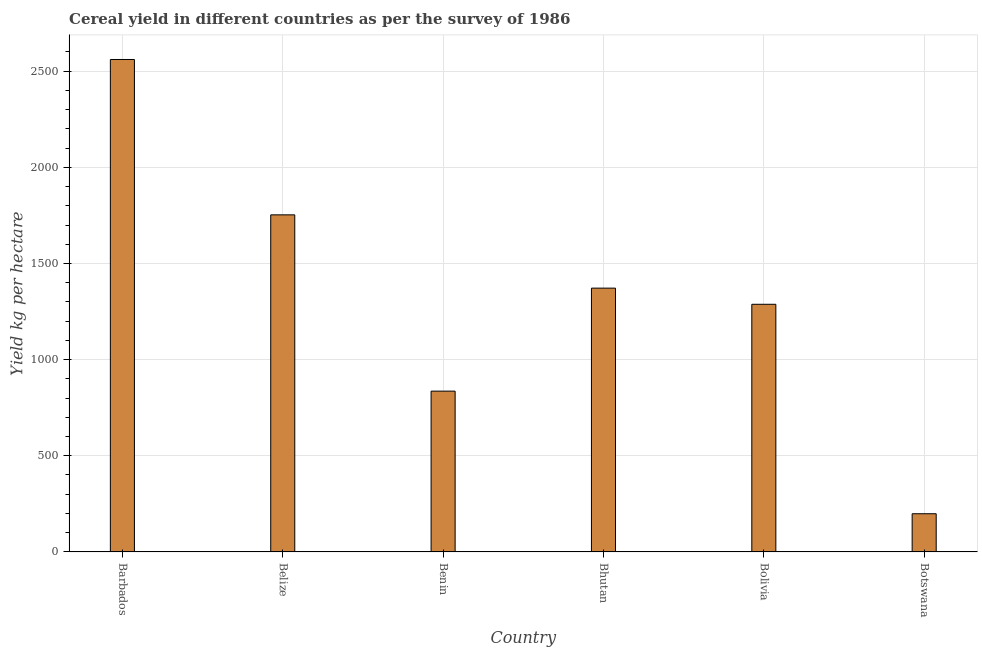Does the graph contain any zero values?
Offer a terse response. No. What is the title of the graph?
Ensure brevity in your answer.  Cereal yield in different countries as per the survey of 1986. What is the label or title of the X-axis?
Make the answer very short. Country. What is the label or title of the Y-axis?
Provide a short and direct response. Yield kg per hectare. What is the cereal yield in Botswana?
Provide a succinct answer. 198.48. Across all countries, what is the maximum cereal yield?
Make the answer very short. 2560.98. Across all countries, what is the minimum cereal yield?
Your response must be concise. 198.48. In which country was the cereal yield maximum?
Offer a very short reply. Barbados. In which country was the cereal yield minimum?
Provide a succinct answer. Botswana. What is the sum of the cereal yield?
Your answer should be compact. 8008.32. What is the difference between the cereal yield in Belize and Bhutan?
Your answer should be very brief. 381.12. What is the average cereal yield per country?
Provide a succinct answer. 1334.72. What is the median cereal yield?
Provide a short and direct response. 1329.86. In how many countries, is the cereal yield greater than 1500 kg per hectare?
Keep it short and to the point. 2. What is the ratio of the cereal yield in Bhutan to that in Bolivia?
Your answer should be very brief. 1.06. Is the cereal yield in Belize less than that in Bolivia?
Your response must be concise. No. Is the difference between the cereal yield in Benin and Bhutan greater than the difference between any two countries?
Your response must be concise. No. What is the difference between the highest and the second highest cereal yield?
Provide a short and direct response. 807.99. Is the sum of the cereal yield in Barbados and Bhutan greater than the maximum cereal yield across all countries?
Your answer should be compact. Yes. What is the difference between the highest and the lowest cereal yield?
Your answer should be very brief. 2362.5. How many bars are there?
Give a very brief answer. 6. What is the Yield kg per hectare of Barbados?
Offer a terse response. 2560.98. What is the Yield kg per hectare of Belize?
Your answer should be very brief. 1752.99. What is the Yield kg per hectare of Benin?
Give a very brief answer. 836.15. What is the Yield kg per hectare of Bhutan?
Offer a very short reply. 1371.87. What is the Yield kg per hectare in Bolivia?
Your answer should be compact. 1287.86. What is the Yield kg per hectare of Botswana?
Offer a very short reply. 198.48. What is the difference between the Yield kg per hectare in Barbados and Belize?
Make the answer very short. 807.99. What is the difference between the Yield kg per hectare in Barbados and Benin?
Provide a succinct answer. 1724.82. What is the difference between the Yield kg per hectare in Barbados and Bhutan?
Your answer should be very brief. 1189.11. What is the difference between the Yield kg per hectare in Barbados and Bolivia?
Your answer should be very brief. 1273.12. What is the difference between the Yield kg per hectare in Barbados and Botswana?
Provide a succinct answer. 2362.5. What is the difference between the Yield kg per hectare in Belize and Benin?
Your response must be concise. 916.83. What is the difference between the Yield kg per hectare in Belize and Bhutan?
Offer a terse response. 381.12. What is the difference between the Yield kg per hectare in Belize and Bolivia?
Your answer should be compact. 465.13. What is the difference between the Yield kg per hectare in Belize and Botswana?
Your answer should be compact. 1554.51. What is the difference between the Yield kg per hectare in Benin and Bhutan?
Give a very brief answer. -535.72. What is the difference between the Yield kg per hectare in Benin and Bolivia?
Offer a very short reply. -451.7. What is the difference between the Yield kg per hectare in Benin and Botswana?
Provide a succinct answer. 637.67. What is the difference between the Yield kg per hectare in Bhutan and Bolivia?
Your response must be concise. 84.01. What is the difference between the Yield kg per hectare in Bhutan and Botswana?
Your answer should be compact. 1173.39. What is the difference between the Yield kg per hectare in Bolivia and Botswana?
Provide a short and direct response. 1089.38. What is the ratio of the Yield kg per hectare in Barbados to that in Belize?
Ensure brevity in your answer.  1.46. What is the ratio of the Yield kg per hectare in Barbados to that in Benin?
Provide a short and direct response. 3.06. What is the ratio of the Yield kg per hectare in Barbados to that in Bhutan?
Keep it short and to the point. 1.87. What is the ratio of the Yield kg per hectare in Barbados to that in Bolivia?
Your response must be concise. 1.99. What is the ratio of the Yield kg per hectare in Barbados to that in Botswana?
Your answer should be compact. 12.9. What is the ratio of the Yield kg per hectare in Belize to that in Benin?
Your response must be concise. 2.1. What is the ratio of the Yield kg per hectare in Belize to that in Bhutan?
Your answer should be compact. 1.28. What is the ratio of the Yield kg per hectare in Belize to that in Bolivia?
Your response must be concise. 1.36. What is the ratio of the Yield kg per hectare in Belize to that in Botswana?
Provide a short and direct response. 8.83. What is the ratio of the Yield kg per hectare in Benin to that in Bhutan?
Provide a short and direct response. 0.61. What is the ratio of the Yield kg per hectare in Benin to that in Bolivia?
Your answer should be compact. 0.65. What is the ratio of the Yield kg per hectare in Benin to that in Botswana?
Offer a very short reply. 4.21. What is the ratio of the Yield kg per hectare in Bhutan to that in Bolivia?
Your response must be concise. 1.06. What is the ratio of the Yield kg per hectare in Bhutan to that in Botswana?
Provide a succinct answer. 6.91. What is the ratio of the Yield kg per hectare in Bolivia to that in Botswana?
Provide a succinct answer. 6.49. 